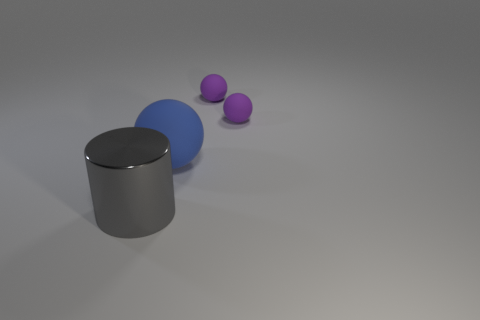Subtract all purple cylinders. Subtract all yellow spheres. How many cylinders are left? 1 Add 1 blue rubber balls. How many objects exist? 5 Subtract all balls. How many objects are left? 1 Subtract 0 brown cylinders. How many objects are left? 4 Subtract all small balls. Subtract all small objects. How many objects are left? 0 Add 2 purple matte things. How many purple matte things are left? 4 Add 2 metallic cylinders. How many metallic cylinders exist? 3 